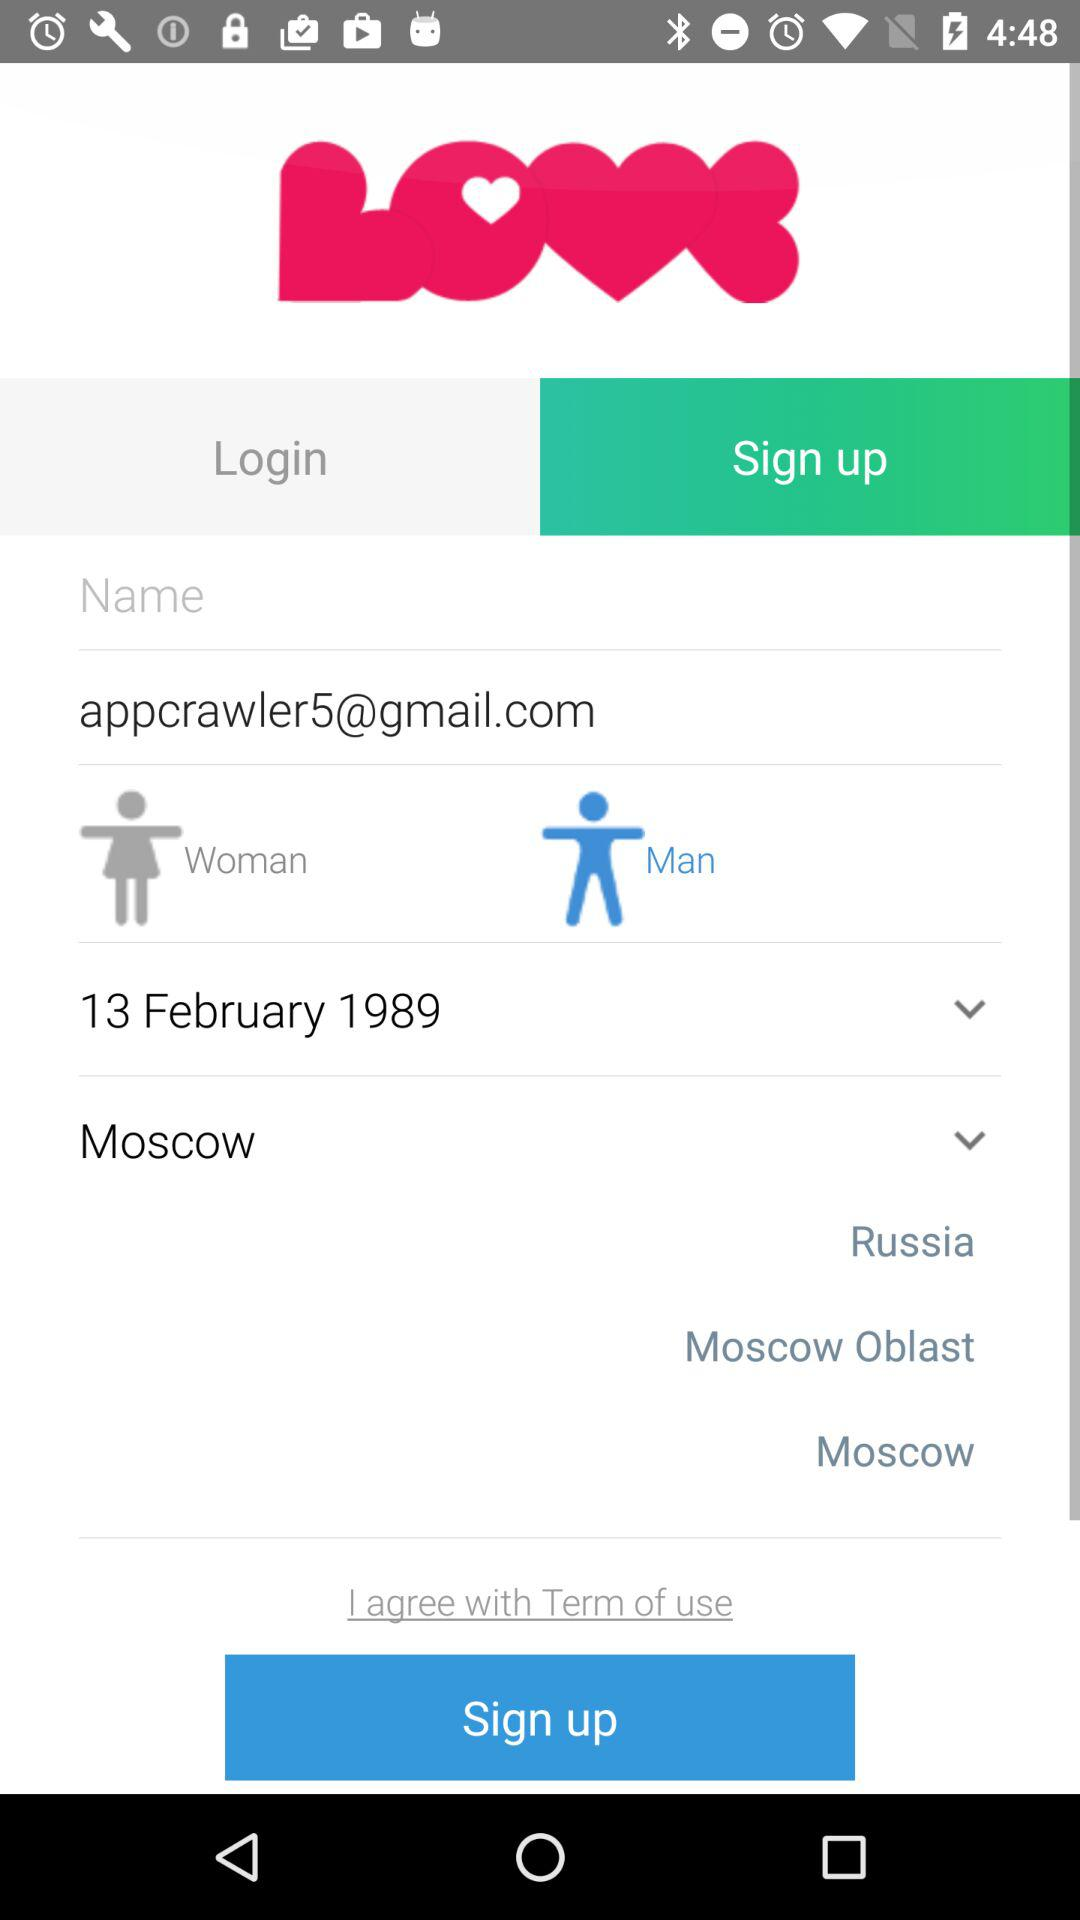Which option is selected in gender? The selected option is "Man". 